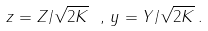Convert formula to latex. <formula><loc_0><loc_0><loc_500><loc_500>z = Z / \sqrt { 2 { K } } \ , \, y = Y / \sqrt { 2 { K } } \, .</formula> 